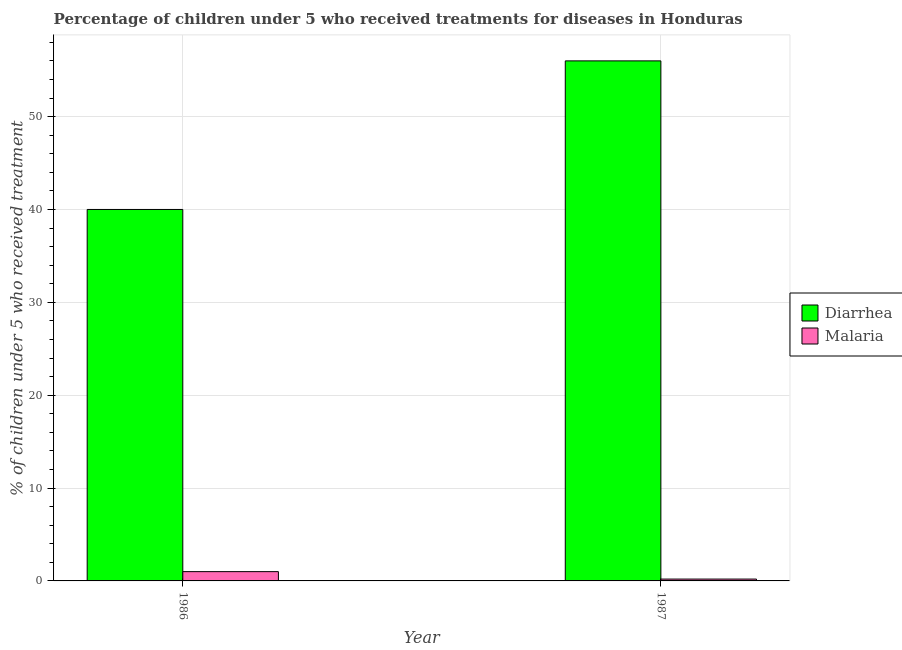How many different coloured bars are there?
Give a very brief answer. 2. How many bars are there on the 2nd tick from the left?
Provide a succinct answer. 2. How many bars are there on the 2nd tick from the right?
Ensure brevity in your answer.  2. What is the label of the 2nd group of bars from the left?
Offer a very short reply. 1987. In how many cases, is the number of bars for a given year not equal to the number of legend labels?
Make the answer very short. 0. Across all years, what is the maximum percentage of children who received treatment for diarrhoea?
Keep it short and to the point. 56. Across all years, what is the minimum percentage of children who received treatment for diarrhoea?
Your answer should be very brief. 40. In which year was the percentage of children who received treatment for malaria maximum?
Provide a short and direct response. 1986. What is the total percentage of children who received treatment for diarrhoea in the graph?
Your answer should be compact. 96. What is the difference between the percentage of children who received treatment for diarrhoea in 1986 and that in 1987?
Offer a very short reply. -16. What is the difference between the percentage of children who received treatment for diarrhoea in 1986 and the percentage of children who received treatment for malaria in 1987?
Keep it short and to the point. -16. What is the average percentage of children who received treatment for malaria per year?
Ensure brevity in your answer.  0.6. In the year 1987, what is the difference between the percentage of children who received treatment for malaria and percentage of children who received treatment for diarrhoea?
Offer a terse response. 0. In how many years, is the percentage of children who received treatment for diarrhoea greater than 20 %?
Your response must be concise. 2. What is the ratio of the percentage of children who received treatment for malaria in 1986 to that in 1987?
Provide a short and direct response. 5. Is the percentage of children who received treatment for malaria in 1986 less than that in 1987?
Offer a terse response. No. In how many years, is the percentage of children who received treatment for diarrhoea greater than the average percentage of children who received treatment for diarrhoea taken over all years?
Your response must be concise. 1. What does the 2nd bar from the left in 1986 represents?
Give a very brief answer. Malaria. What does the 2nd bar from the right in 1987 represents?
Your answer should be compact. Diarrhea. Are all the bars in the graph horizontal?
Your answer should be compact. No. What is the difference between two consecutive major ticks on the Y-axis?
Keep it short and to the point. 10. Are the values on the major ticks of Y-axis written in scientific E-notation?
Give a very brief answer. No. Does the graph contain any zero values?
Keep it short and to the point. No. How many legend labels are there?
Keep it short and to the point. 2. What is the title of the graph?
Give a very brief answer. Percentage of children under 5 who received treatments for diseases in Honduras. What is the label or title of the X-axis?
Keep it short and to the point. Year. What is the label or title of the Y-axis?
Keep it short and to the point. % of children under 5 who received treatment. What is the % of children under 5 who received treatment in Diarrhea in 1986?
Give a very brief answer. 40. What is the % of children under 5 who received treatment in Malaria in 1986?
Make the answer very short. 1. What is the % of children under 5 who received treatment of Diarrhea in 1987?
Give a very brief answer. 56. What is the % of children under 5 who received treatment in Malaria in 1987?
Your answer should be very brief. 0.2. What is the total % of children under 5 who received treatment of Diarrhea in the graph?
Offer a very short reply. 96. What is the difference between the % of children under 5 who received treatment in Diarrhea in 1986 and that in 1987?
Provide a succinct answer. -16. What is the difference between the % of children under 5 who received treatment of Diarrhea in 1986 and the % of children under 5 who received treatment of Malaria in 1987?
Your response must be concise. 39.8. What is the average % of children under 5 who received treatment in Malaria per year?
Ensure brevity in your answer.  0.6. In the year 1987, what is the difference between the % of children under 5 who received treatment in Diarrhea and % of children under 5 who received treatment in Malaria?
Your response must be concise. 55.8. What is the difference between the highest and the second highest % of children under 5 who received treatment in Diarrhea?
Make the answer very short. 16. What is the difference between the highest and the second highest % of children under 5 who received treatment in Malaria?
Your answer should be very brief. 0.8. 